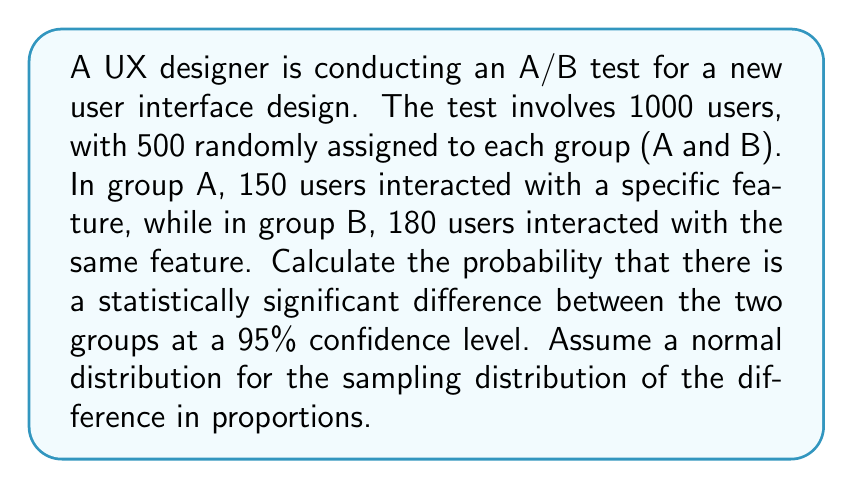Could you help me with this problem? To solve this problem, we'll use the z-test for the difference between two proportions. Here's the step-by-step process:

1. Calculate the proportions for each group:
   $p_A = \frac{150}{500} = 0.3$
   $p_B = \frac{180}{500} = 0.36$

2. Calculate the pooled proportion:
   $p = \frac{150 + 180}{1000} = 0.33$

3. Calculate the standard error of the difference in proportions:
   $SE = \sqrt{p(1-p)(\frac{1}{n_A} + \frac{1}{n_B})}$
   $SE = \sqrt{0.33(1-0.33)(\frac{1}{500} + \frac{1}{500})} \approx 0.0297$

4. Calculate the z-score:
   $z = \frac{p_B - p_A}{SE} = \frac{0.36 - 0.3}{0.0297} \approx 2.02$

5. For a 95% confidence level, the critical z-value is 1.96 (two-tailed test).

6. Since our calculated z-score (2.02) is greater than the critical z-value (1.96), we reject the null hypothesis.

7. To find the probability of a statistically significant difference, we need to calculate the p-value:
   $p-value = 2 * (1 - \Phi(|z|))$
   where $\Phi$ is the cumulative distribution function of the standard normal distribution.

8. Using a standard normal distribution table or calculator:
   $p-value = 2 * (1 - \Phi(2.02)) \approx 0.0434$

9. The probability of a statistically significant difference is:
   $1 - p-value \approx 1 - 0.0434 = 0.9566$
Answer: The probability of a statistically significant difference between the two groups at a 95% confidence level is approximately 0.9566 or 95.66%. 